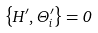Convert formula to latex. <formula><loc_0><loc_0><loc_500><loc_500>\left \{ H ^ { \prime } , \Theta _ { i } ^ { \prime } \right \} = 0</formula> 